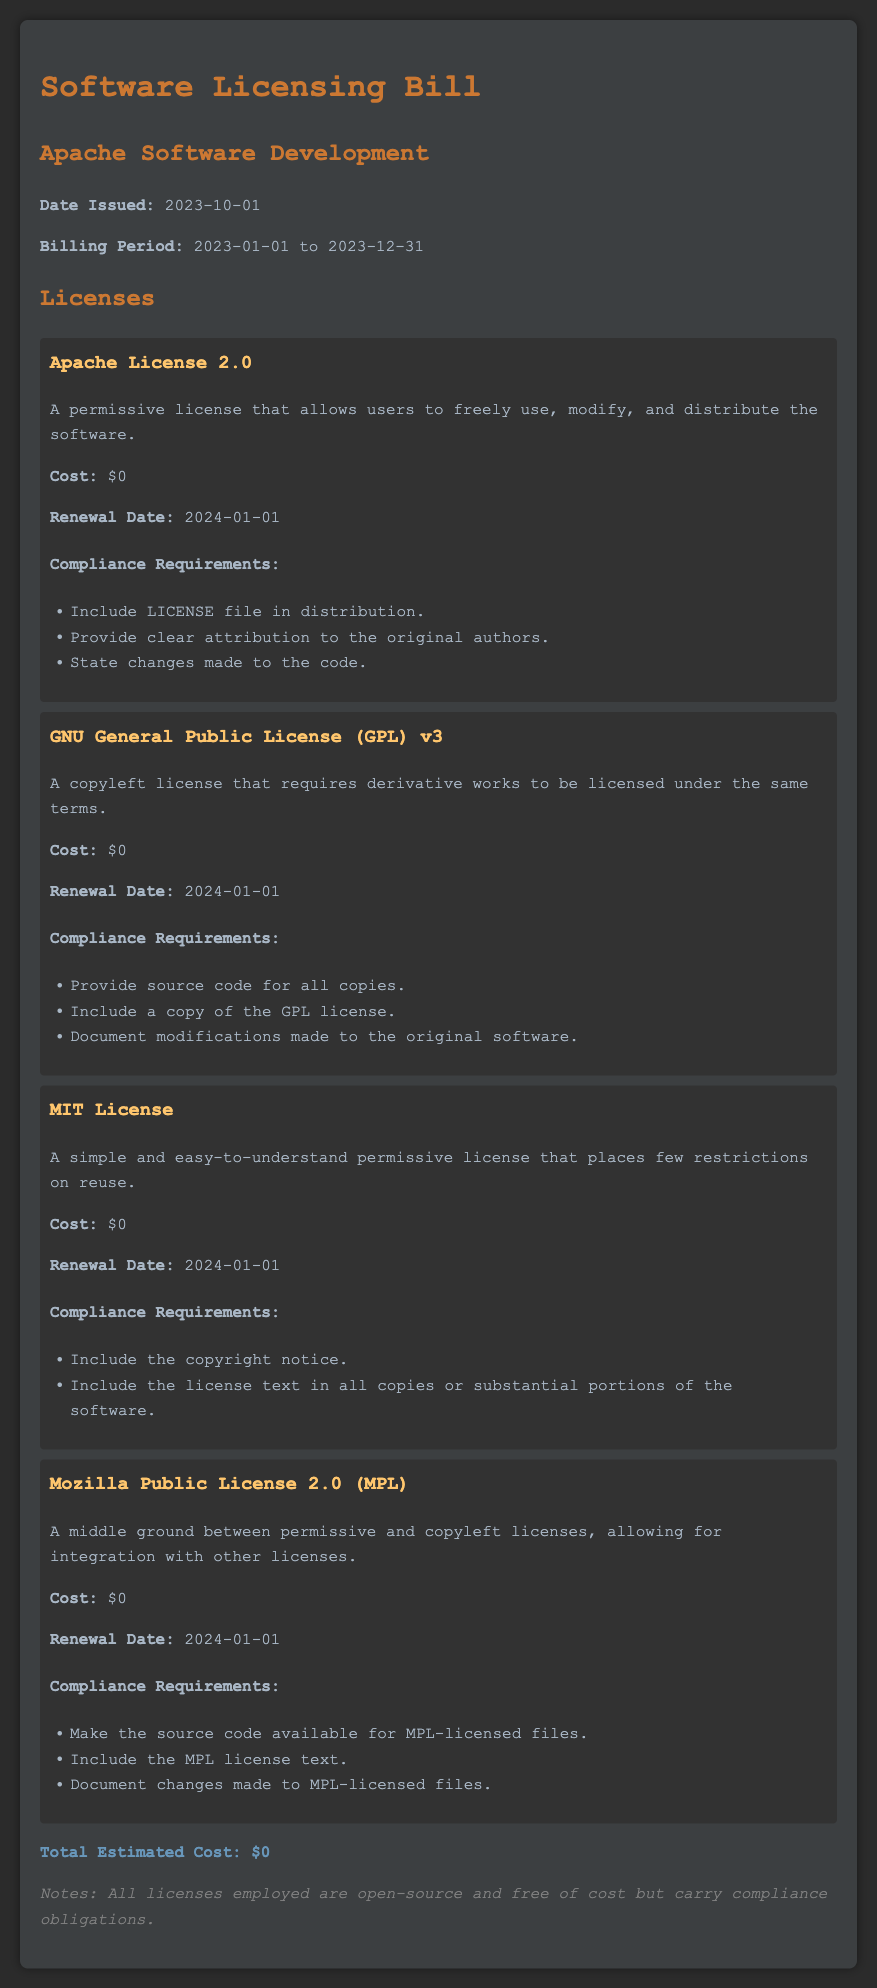What is the title of the document? The title of the document is mentioned in the header.
Answer: Software Licensing Bill When was the document issued? The date issued is specified in the introductory section.
Answer: 2023-10-01 What is the billing period? The billing period is indicated in the document along with the date issued.
Answer: 2023-01-01 to 2023-12-31 What is the cost of the Apache License 2.0? The cost for the Apache License 2.0 is provided in the license section.
Answer: $0 When is the renewal date for all licenses listed? The renewal dates are uniform across all licenses mentioned in the document.
Answer: 2024-01-01 What is a compliance requirement for the GNU General Public License (GPL) v3? The compliance requirements for each license are listed in their respective sections.
Answer: Provide source code for all copies How many licenses are listed in the document? The number of licenses is counted from the licenses section presented in the document.
Answer: 4 What is the total estimated cost stated at the end of the document? The total estimated cost is summarized at the conclusion of the license section.
Answer: $0 What type of licenses are included in this bill? The type of licenses is indicated through the descriptions provided for each license.
Answer: Open-source licenses 